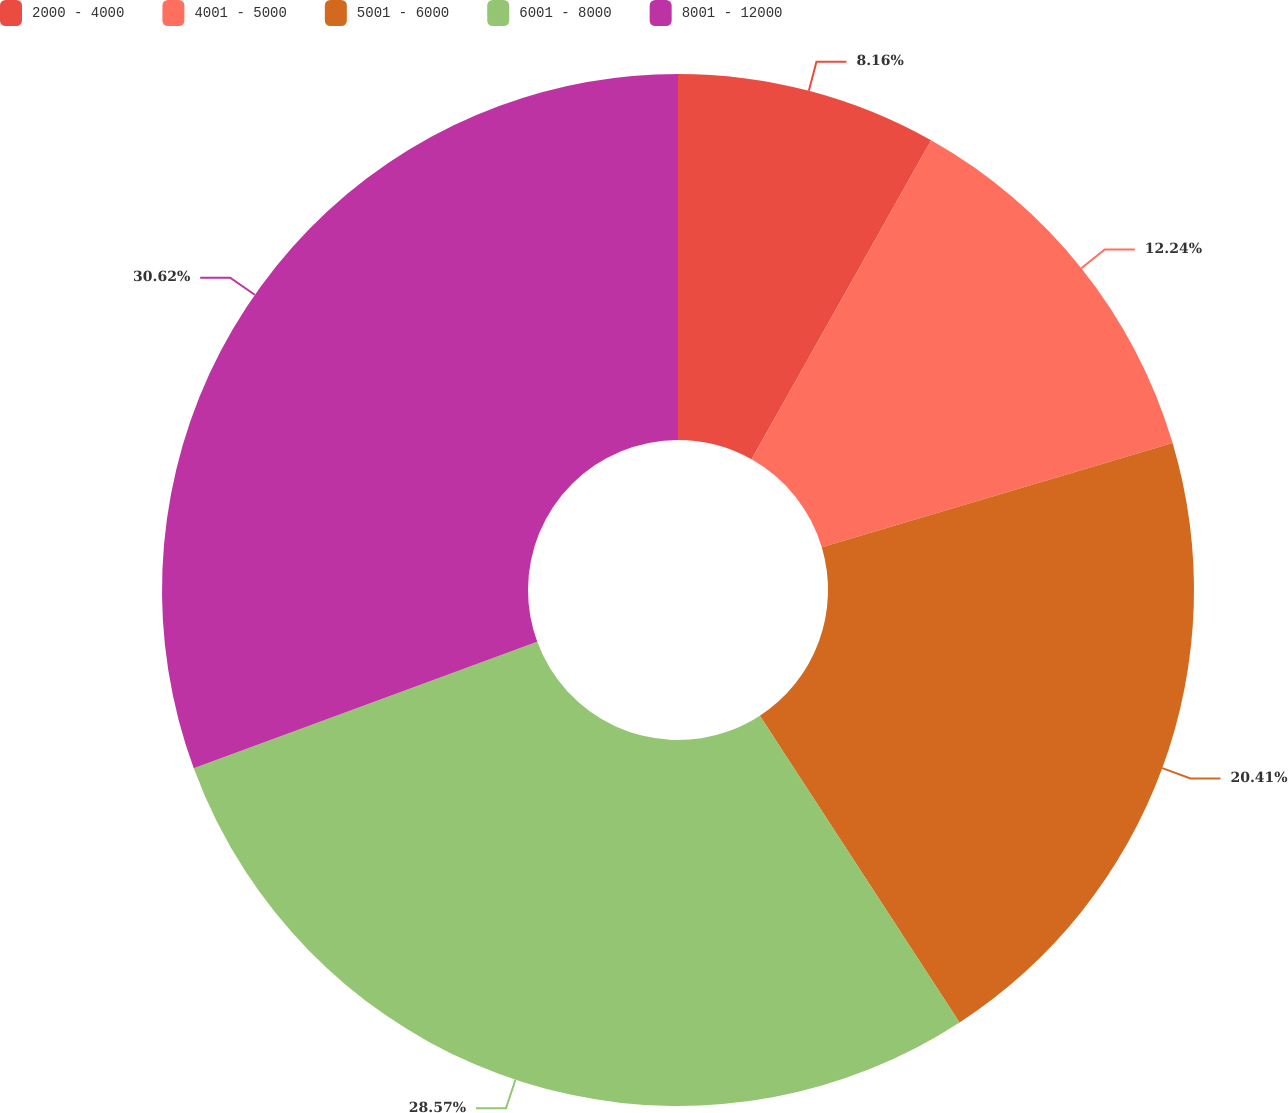Convert chart. <chart><loc_0><loc_0><loc_500><loc_500><pie_chart><fcel>2000 - 4000<fcel>4001 - 5000<fcel>5001 - 6000<fcel>6001 - 8000<fcel>8001 - 12000<nl><fcel>8.16%<fcel>12.24%<fcel>20.41%<fcel>28.57%<fcel>30.61%<nl></chart> 